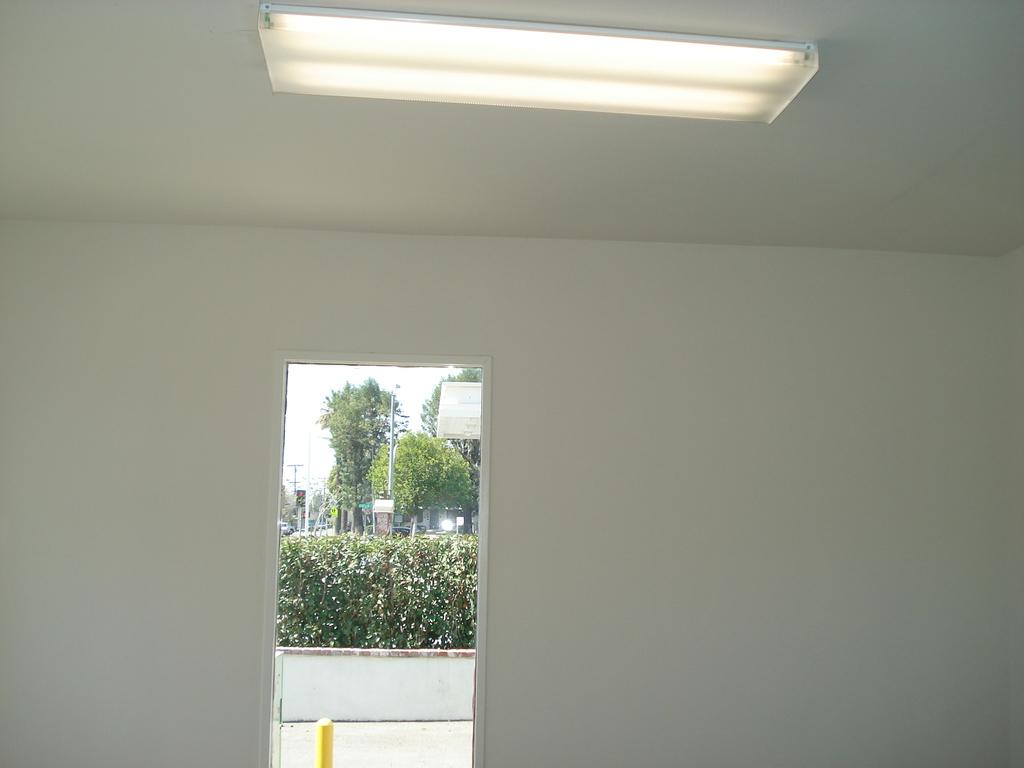What type of vegetation can be seen in the image? There are shrubs and trees in the image. What structures are present in the image? There are poles in the image. Is there any source of illumination visible in the image? Yes, there is a light in the image. How many chickens are perched on the poles in the image? There are no chickens present in the image. What type of love is being expressed by the trees in the image? The trees in the image are not expressing any type of love; they are simply trees. 